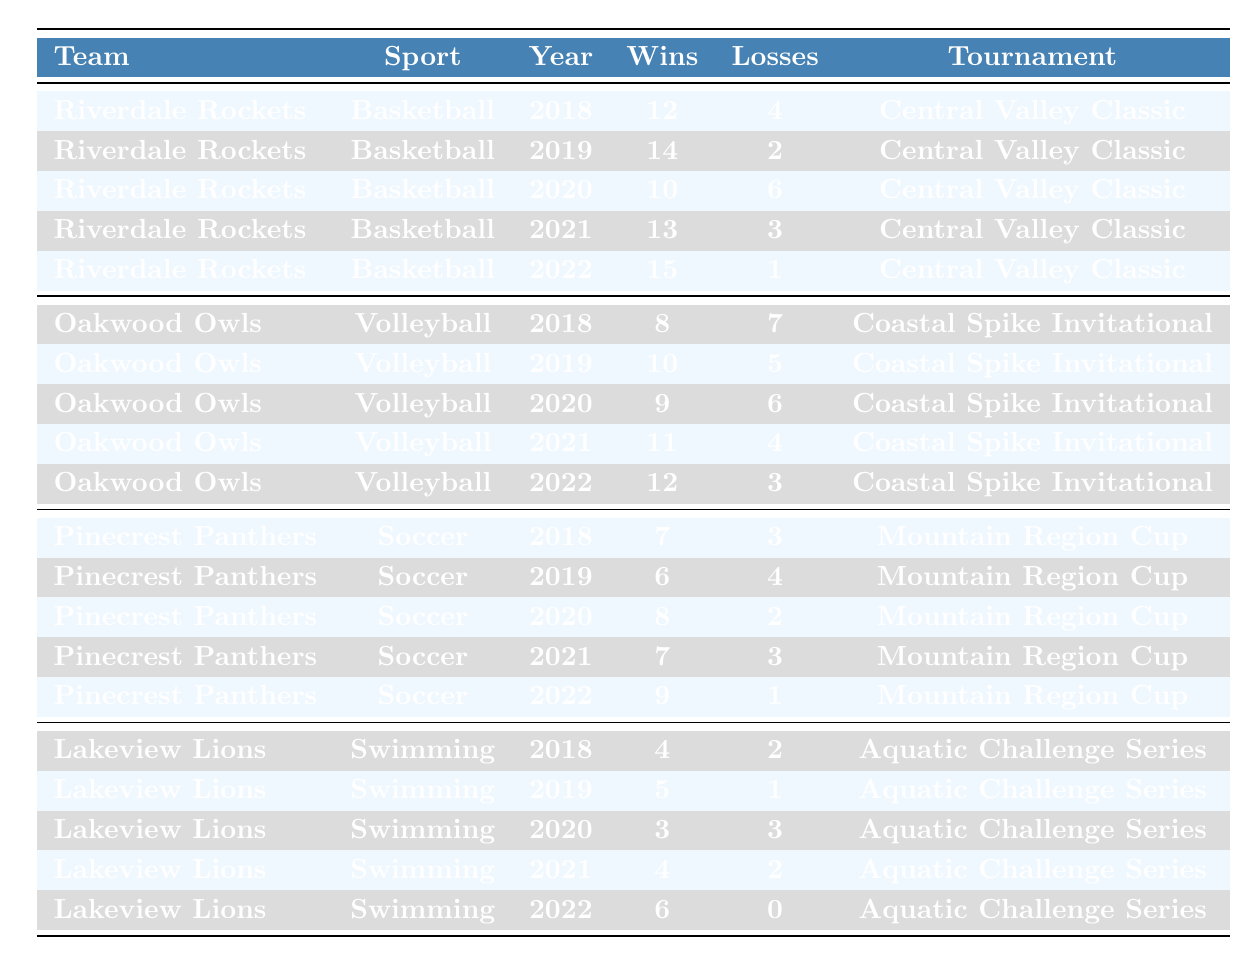What team had the highest number of wins in 2022? Referring to the table, Riverdale Rockets had 15 wins in 2022, which is the highest compared to other teams in that year.
Answer: Riverdale Rockets How many total wins did the Oakwood Owls achieve from 2018 to 2022? The total wins for Oakwood Owls from 2018 to 2022 are calculated as follows: 8 + 10 + 9 + 11 + 12 = 50.
Answer: 50 Did the Pinecrest Panthers lose more than 3 matches in any year? In 2019, Pinecrest Panthers lost 4 matches, which is more than 3. Therefore, the answer is yes.
Answer: Yes Which team improved its performance the most from 2018 to 2022 based on wins? Riverdale Rockets had 12 wins in 2018 and 15 wins in 2022, resulting in an improvement of 3 wins. Oakwood Owls improved by 4 wins (8 in 2018 to 12 in 2022) and the Pinecrest Panthers improved by 2 wins (7 in 2018 to 9 in 2022). Thus, Oakwood Owls improved the most, with a total increase of 4 wins.
Answer: Oakwood Owls What is the average number of losses per year for the Lakeview Lions over the five years? Adding their losses: 2 + 1 + 3 + 2 + 0 = 8. Dividing by 5 years gives an average of 8 / 5 = 1.6.
Answer: 1.6 How many tournaments did each team participate in? Each team appears in the table for 5 years which indicates participation in the same tournament for consecutive years. Therefore, each team participated in 5 tournaments across five years.
Answer: 5 What was the total number of wins across all teams in 2021? Adding the wins for 2021: Riverdale Rockets (13) + Oakwood Owls (11) + Pinecrest Panthers (7) + Lakeview Lions (4) = 35 wins.
Answer: 35 Which sport had the most consistent performance based on win-loss records? Analyzing the win-loss patterns, the Riverdale Rockets consistently had high wins and low losses each year, suggesting consistent performance. Thus, basketball appears to be the most consistent sport among the listed teams.
Answer: Basketball 